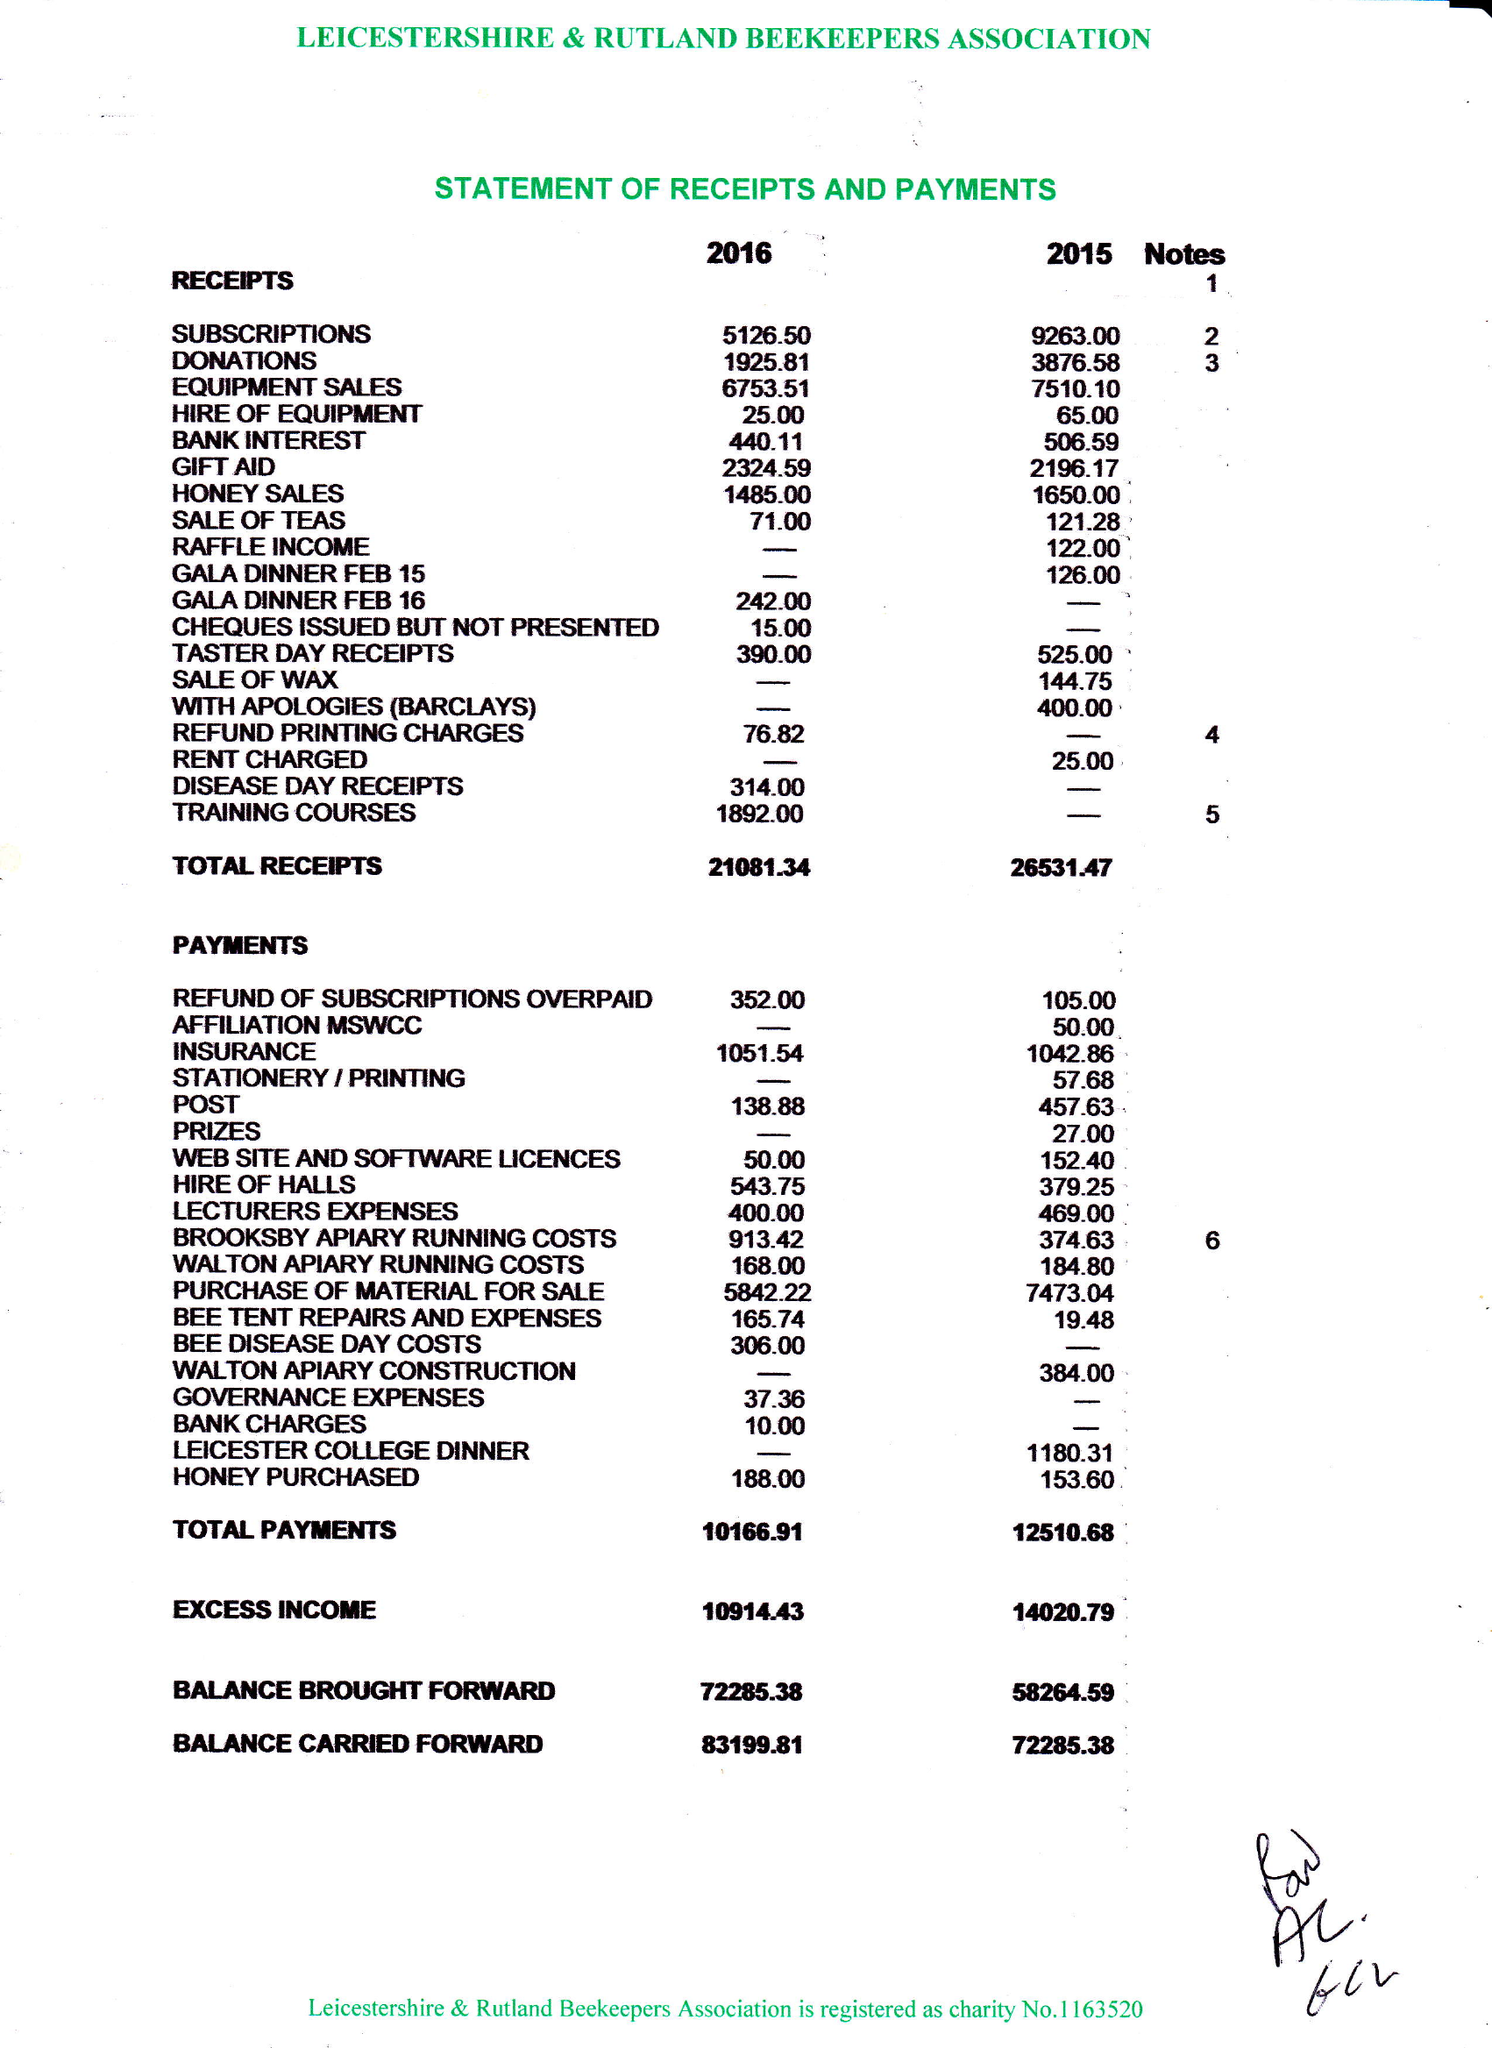What is the value for the spending_annually_in_british_pounds?
Answer the question using a single word or phrase. 10167.00 